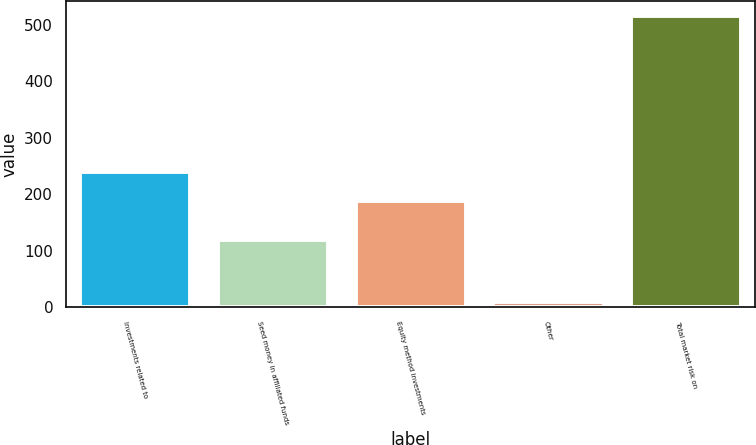Convert chart. <chart><loc_0><loc_0><loc_500><loc_500><bar_chart><fcel>Investments related to<fcel>Seed money in affiliated funds<fcel>Equity method investments<fcel>Other<fcel>Total market risk on<nl><fcel>238.93<fcel>119.4<fcel>188.3<fcel>9<fcel>515.3<nl></chart> 